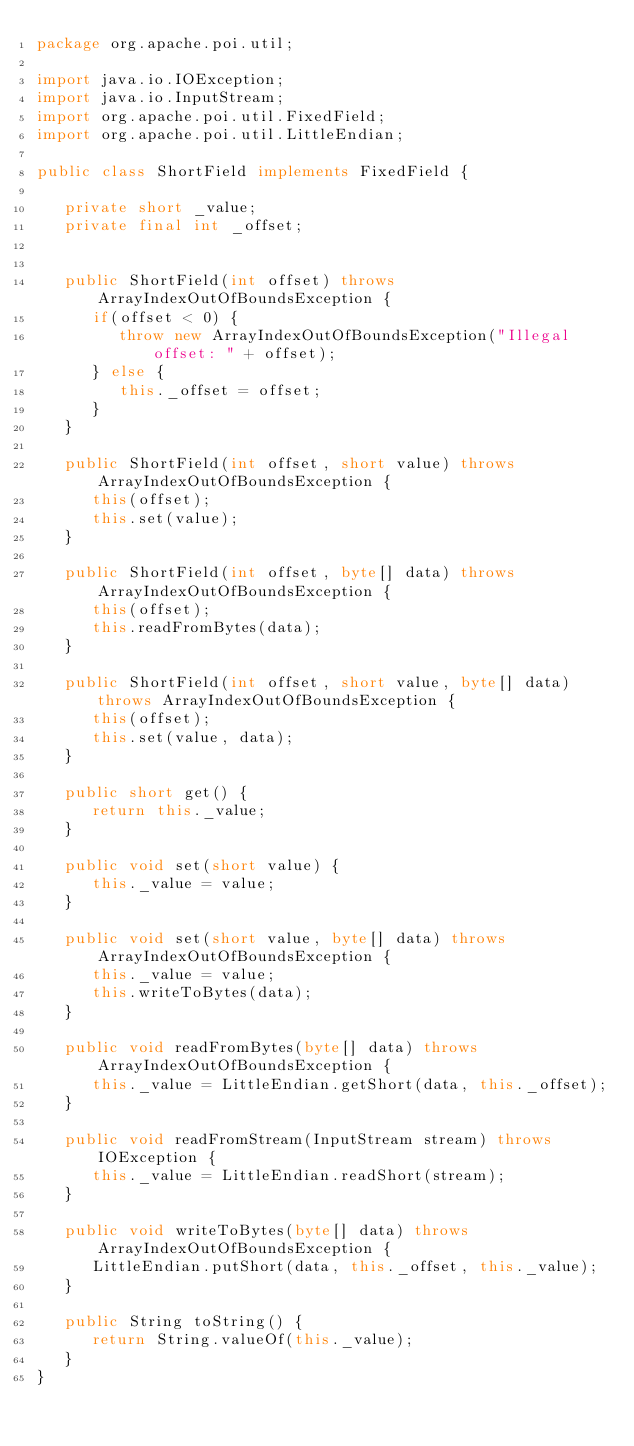<code> <loc_0><loc_0><loc_500><loc_500><_Java_>package org.apache.poi.util;

import java.io.IOException;
import java.io.InputStream;
import org.apache.poi.util.FixedField;
import org.apache.poi.util.LittleEndian;

public class ShortField implements FixedField {

   private short _value;
   private final int _offset;


   public ShortField(int offset) throws ArrayIndexOutOfBoundsException {
      if(offset < 0) {
         throw new ArrayIndexOutOfBoundsException("Illegal offset: " + offset);
      } else {
         this._offset = offset;
      }
   }

   public ShortField(int offset, short value) throws ArrayIndexOutOfBoundsException {
      this(offset);
      this.set(value);
   }

   public ShortField(int offset, byte[] data) throws ArrayIndexOutOfBoundsException {
      this(offset);
      this.readFromBytes(data);
   }

   public ShortField(int offset, short value, byte[] data) throws ArrayIndexOutOfBoundsException {
      this(offset);
      this.set(value, data);
   }

   public short get() {
      return this._value;
   }

   public void set(short value) {
      this._value = value;
   }

   public void set(short value, byte[] data) throws ArrayIndexOutOfBoundsException {
      this._value = value;
      this.writeToBytes(data);
   }

   public void readFromBytes(byte[] data) throws ArrayIndexOutOfBoundsException {
      this._value = LittleEndian.getShort(data, this._offset);
   }

   public void readFromStream(InputStream stream) throws IOException {
      this._value = LittleEndian.readShort(stream);
   }

   public void writeToBytes(byte[] data) throws ArrayIndexOutOfBoundsException {
      LittleEndian.putShort(data, this._offset, this._value);
   }

   public String toString() {
      return String.valueOf(this._value);
   }
}
</code> 